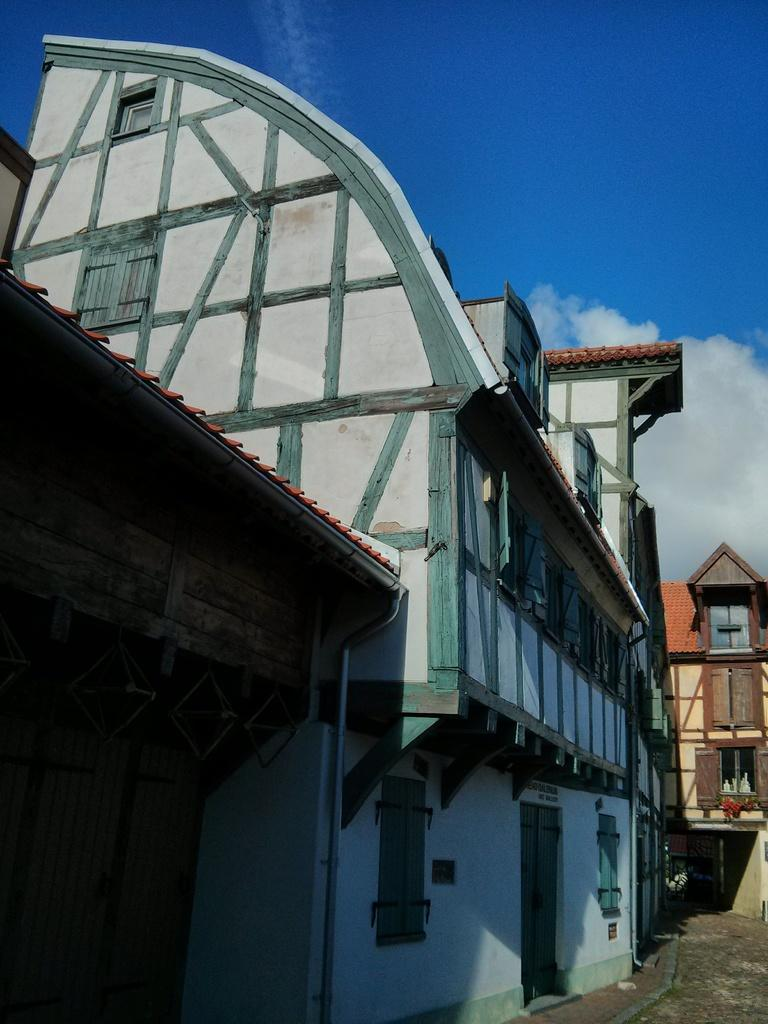What type of structures can be seen in the image? There are houses in the image. What is the color of the sky in the image? The sky is blue in the image. Are there any weather elements visible in the sky in the image? Yes, there are clouds visible in the sky in the image. What type of underwear is hanging on the clothesline in the image? There is no clothesline or underwear present in the image. 